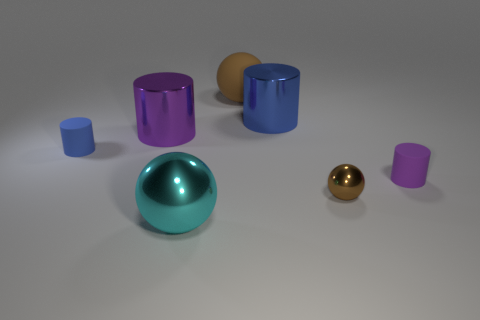Subtract all brown cylinders. Subtract all green spheres. How many cylinders are left? 4 Add 1 purple rubber things. How many objects exist? 8 Subtract all cylinders. How many objects are left? 3 Add 2 rubber spheres. How many rubber spheres are left? 3 Add 1 purple cylinders. How many purple cylinders exist? 3 Subtract 0 yellow balls. How many objects are left? 7 Subtract all brown metal objects. Subtract all matte cubes. How many objects are left? 6 